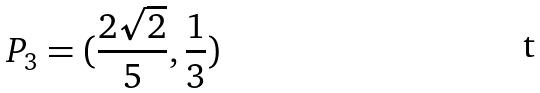<formula> <loc_0><loc_0><loc_500><loc_500>P _ { 3 } = ( \frac { 2 \sqrt { 2 } } { 5 } , \frac { 1 } { 3 } )</formula> 